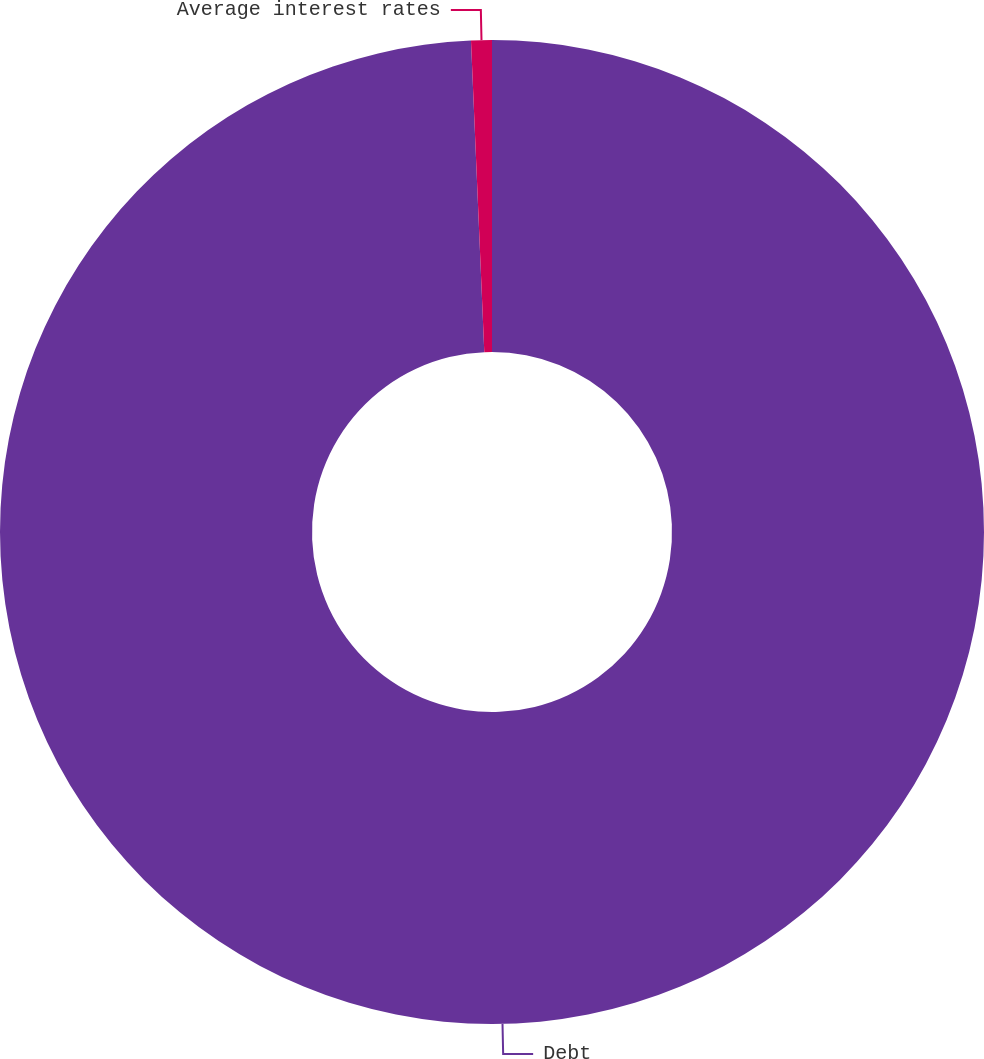Convert chart to OTSL. <chart><loc_0><loc_0><loc_500><loc_500><pie_chart><fcel>Debt<fcel>Average interest rates<nl><fcel>99.32%<fcel>0.68%<nl></chart> 